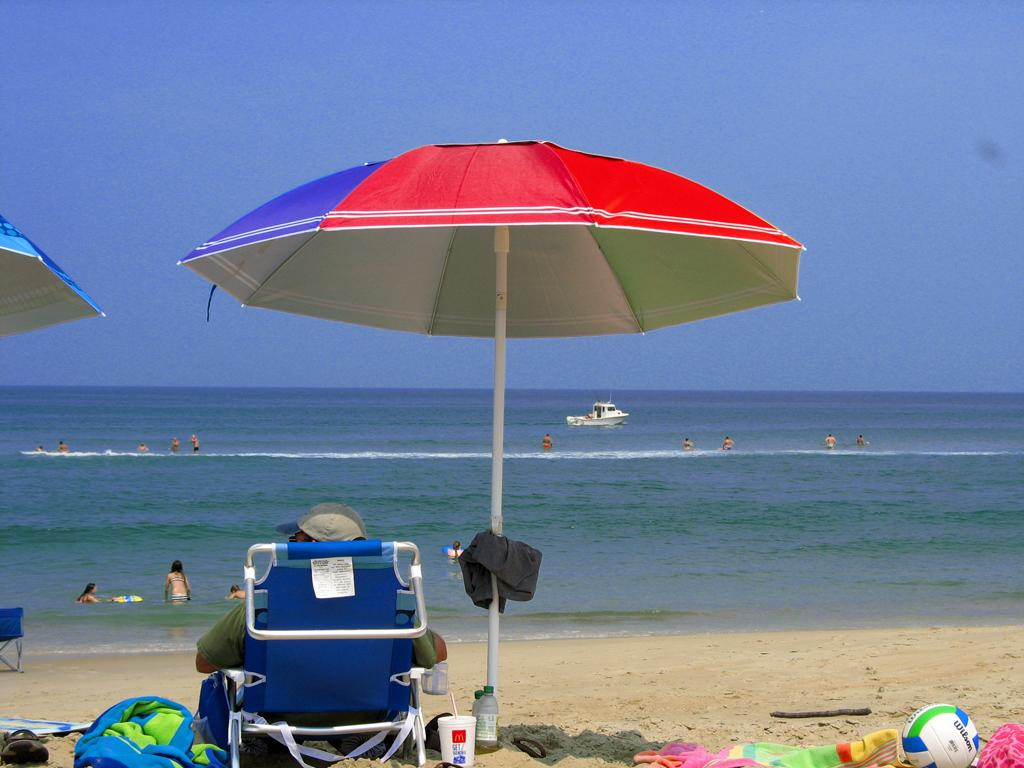What is the person in the image doing? The person is sitting on a chair in the image. What is providing shade for the person? The person is under an umbrella. Where is the location of the image? The location is a beach. What can be seen in front of the person? There is an ocean in front of the person. What are some activities happening in the ocean? People are swimming in the ocean, and there is a boat in the ocean. What is visible above the ocean? The sky is visible above the ocean. What territory is the person claiming by sitting on the chair in the image? There is no indication in the image that the person is claiming any territory by sitting on the chair. Can you see any snakes in the image? There are no snakes visible in the image. 